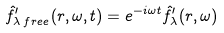<formula> <loc_0><loc_0><loc_500><loc_500>\hat { f } ^ { \prime } _ { \lambda \, f r e e } ( r , \omega , t ) = e ^ { - i \omega t } \hat { f } ^ { \prime } _ { \lambda } ( r , \omega )</formula> 